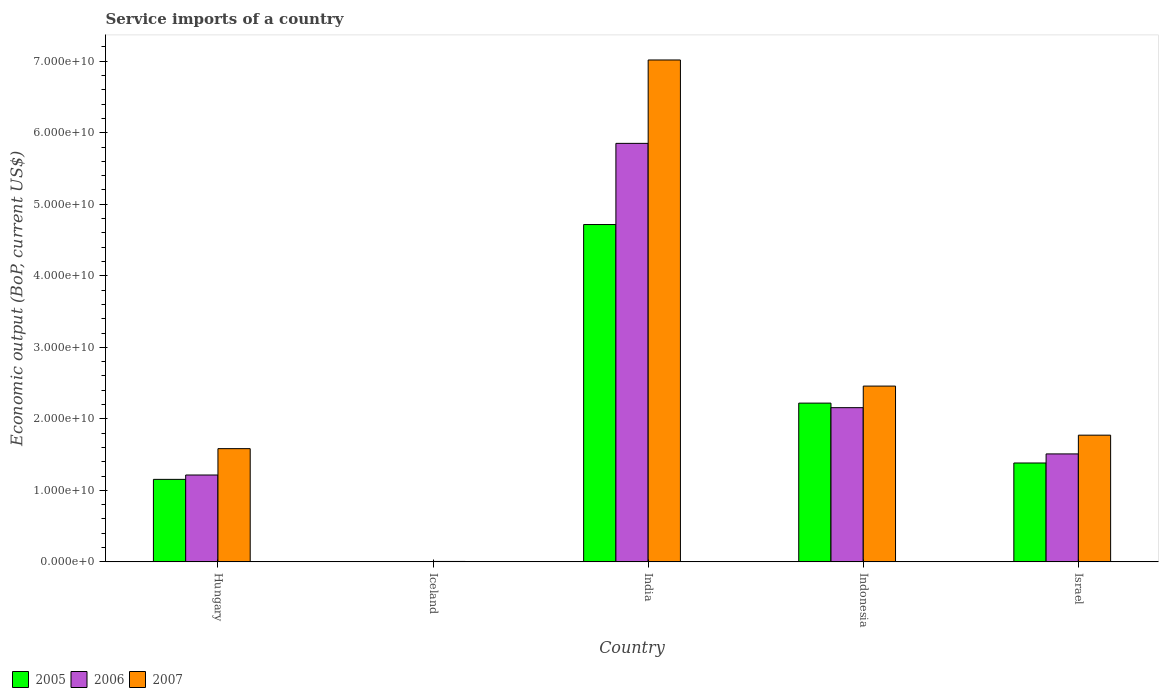How many different coloured bars are there?
Your answer should be very brief. 3. What is the label of the 2nd group of bars from the left?
Keep it short and to the point. Iceland. What is the service imports in 2007 in Israel?
Ensure brevity in your answer.  1.77e+1. Across all countries, what is the maximum service imports in 2007?
Keep it short and to the point. 7.02e+1. Across all countries, what is the minimum service imports in 2006?
Offer a terse response. 2.89e+07. In which country was the service imports in 2007 maximum?
Make the answer very short. India. In which country was the service imports in 2006 minimum?
Provide a succinct answer. Iceland. What is the total service imports in 2007 in the graph?
Provide a short and direct response. 1.28e+11. What is the difference between the service imports in 2007 in India and that in Israel?
Ensure brevity in your answer.  5.25e+1. What is the difference between the service imports in 2006 in Iceland and the service imports in 2007 in India?
Your answer should be very brief. -7.01e+1. What is the average service imports in 2006 per country?
Make the answer very short. 2.15e+1. What is the difference between the service imports of/in 2006 and service imports of/in 2007 in Israel?
Your answer should be very brief. -2.62e+09. In how many countries, is the service imports in 2006 greater than 46000000000 US$?
Give a very brief answer. 1. What is the ratio of the service imports in 2005 in Iceland to that in India?
Provide a short and direct response. 0. Is the service imports in 2007 in Iceland less than that in Indonesia?
Offer a terse response. Yes. What is the difference between the highest and the second highest service imports in 2006?
Make the answer very short. -4.34e+1. What is the difference between the highest and the lowest service imports in 2005?
Offer a terse response. 4.72e+1. Is it the case that in every country, the sum of the service imports in 2006 and service imports in 2005 is greater than the service imports in 2007?
Give a very brief answer. No. Are all the bars in the graph horizontal?
Your answer should be very brief. No. How many countries are there in the graph?
Provide a succinct answer. 5. Does the graph contain any zero values?
Provide a short and direct response. No. Does the graph contain grids?
Ensure brevity in your answer.  No. Where does the legend appear in the graph?
Keep it short and to the point. Bottom left. How are the legend labels stacked?
Your response must be concise. Horizontal. What is the title of the graph?
Keep it short and to the point. Service imports of a country. Does "2008" appear as one of the legend labels in the graph?
Ensure brevity in your answer.  No. What is the label or title of the Y-axis?
Offer a terse response. Economic output (BoP, current US$). What is the Economic output (BoP, current US$) of 2005 in Hungary?
Your response must be concise. 1.15e+1. What is the Economic output (BoP, current US$) of 2006 in Hungary?
Provide a short and direct response. 1.21e+1. What is the Economic output (BoP, current US$) of 2007 in Hungary?
Provide a short and direct response. 1.58e+1. What is the Economic output (BoP, current US$) of 2005 in Iceland?
Keep it short and to the point. 1.32e+07. What is the Economic output (BoP, current US$) in 2006 in Iceland?
Offer a very short reply. 2.89e+07. What is the Economic output (BoP, current US$) in 2007 in Iceland?
Offer a very short reply. 5.90e+07. What is the Economic output (BoP, current US$) in 2005 in India?
Give a very brief answer. 4.72e+1. What is the Economic output (BoP, current US$) in 2006 in India?
Provide a short and direct response. 5.85e+1. What is the Economic output (BoP, current US$) in 2007 in India?
Ensure brevity in your answer.  7.02e+1. What is the Economic output (BoP, current US$) of 2005 in Indonesia?
Provide a short and direct response. 2.22e+1. What is the Economic output (BoP, current US$) of 2006 in Indonesia?
Offer a very short reply. 2.16e+1. What is the Economic output (BoP, current US$) in 2007 in Indonesia?
Make the answer very short. 2.46e+1. What is the Economic output (BoP, current US$) in 2005 in Israel?
Offer a terse response. 1.38e+1. What is the Economic output (BoP, current US$) in 2006 in Israel?
Provide a short and direct response. 1.51e+1. What is the Economic output (BoP, current US$) in 2007 in Israel?
Give a very brief answer. 1.77e+1. Across all countries, what is the maximum Economic output (BoP, current US$) in 2005?
Make the answer very short. 4.72e+1. Across all countries, what is the maximum Economic output (BoP, current US$) of 2006?
Make the answer very short. 5.85e+1. Across all countries, what is the maximum Economic output (BoP, current US$) of 2007?
Give a very brief answer. 7.02e+1. Across all countries, what is the minimum Economic output (BoP, current US$) in 2005?
Offer a terse response. 1.32e+07. Across all countries, what is the minimum Economic output (BoP, current US$) of 2006?
Ensure brevity in your answer.  2.89e+07. Across all countries, what is the minimum Economic output (BoP, current US$) of 2007?
Your answer should be very brief. 5.90e+07. What is the total Economic output (BoP, current US$) of 2005 in the graph?
Offer a very short reply. 9.47e+1. What is the total Economic output (BoP, current US$) in 2006 in the graph?
Ensure brevity in your answer.  1.07e+11. What is the total Economic output (BoP, current US$) in 2007 in the graph?
Offer a terse response. 1.28e+11. What is the difference between the Economic output (BoP, current US$) of 2005 in Hungary and that in Iceland?
Make the answer very short. 1.15e+1. What is the difference between the Economic output (BoP, current US$) of 2006 in Hungary and that in Iceland?
Keep it short and to the point. 1.21e+1. What is the difference between the Economic output (BoP, current US$) of 2007 in Hungary and that in Iceland?
Your answer should be very brief. 1.58e+1. What is the difference between the Economic output (BoP, current US$) in 2005 in Hungary and that in India?
Provide a short and direct response. -3.56e+1. What is the difference between the Economic output (BoP, current US$) of 2006 in Hungary and that in India?
Provide a short and direct response. -4.64e+1. What is the difference between the Economic output (BoP, current US$) in 2007 in Hungary and that in India?
Your response must be concise. -5.43e+1. What is the difference between the Economic output (BoP, current US$) of 2005 in Hungary and that in Indonesia?
Offer a terse response. -1.07e+1. What is the difference between the Economic output (BoP, current US$) in 2006 in Hungary and that in Indonesia?
Offer a terse response. -9.42e+09. What is the difference between the Economic output (BoP, current US$) in 2007 in Hungary and that in Indonesia?
Your response must be concise. -8.75e+09. What is the difference between the Economic output (BoP, current US$) of 2005 in Hungary and that in Israel?
Give a very brief answer. -2.29e+09. What is the difference between the Economic output (BoP, current US$) of 2006 in Hungary and that in Israel?
Offer a very short reply. -2.95e+09. What is the difference between the Economic output (BoP, current US$) in 2007 in Hungary and that in Israel?
Give a very brief answer. -1.89e+09. What is the difference between the Economic output (BoP, current US$) in 2005 in Iceland and that in India?
Keep it short and to the point. -4.72e+1. What is the difference between the Economic output (BoP, current US$) of 2006 in Iceland and that in India?
Make the answer very short. -5.85e+1. What is the difference between the Economic output (BoP, current US$) of 2007 in Iceland and that in India?
Provide a short and direct response. -7.01e+1. What is the difference between the Economic output (BoP, current US$) in 2005 in Iceland and that in Indonesia?
Your answer should be very brief. -2.22e+1. What is the difference between the Economic output (BoP, current US$) of 2006 in Iceland and that in Indonesia?
Make the answer very short. -2.15e+1. What is the difference between the Economic output (BoP, current US$) of 2007 in Iceland and that in Indonesia?
Offer a terse response. -2.45e+1. What is the difference between the Economic output (BoP, current US$) in 2005 in Iceland and that in Israel?
Your answer should be compact. -1.38e+1. What is the difference between the Economic output (BoP, current US$) of 2006 in Iceland and that in Israel?
Provide a short and direct response. -1.51e+1. What is the difference between the Economic output (BoP, current US$) in 2007 in Iceland and that in Israel?
Your answer should be very brief. -1.77e+1. What is the difference between the Economic output (BoP, current US$) of 2005 in India and that in Indonesia?
Your response must be concise. 2.50e+1. What is the difference between the Economic output (BoP, current US$) of 2006 in India and that in Indonesia?
Provide a short and direct response. 3.70e+1. What is the difference between the Economic output (BoP, current US$) of 2007 in India and that in Indonesia?
Give a very brief answer. 4.56e+1. What is the difference between the Economic output (BoP, current US$) in 2005 in India and that in Israel?
Ensure brevity in your answer.  3.33e+1. What is the difference between the Economic output (BoP, current US$) in 2006 in India and that in Israel?
Keep it short and to the point. 4.34e+1. What is the difference between the Economic output (BoP, current US$) in 2007 in India and that in Israel?
Provide a succinct answer. 5.25e+1. What is the difference between the Economic output (BoP, current US$) in 2005 in Indonesia and that in Israel?
Offer a very short reply. 8.37e+09. What is the difference between the Economic output (BoP, current US$) in 2006 in Indonesia and that in Israel?
Give a very brief answer. 6.47e+09. What is the difference between the Economic output (BoP, current US$) of 2007 in Indonesia and that in Israel?
Ensure brevity in your answer.  6.86e+09. What is the difference between the Economic output (BoP, current US$) of 2005 in Hungary and the Economic output (BoP, current US$) of 2006 in Iceland?
Provide a short and direct response. 1.15e+1. What is the difference between the Economic output (BoP, current US$) of 2005 in Hungary and the Economic output (BoP, current US$) of 2007 in Iceland?
Your response must be concise. 1.15e+1. What is the difference between the Economic output (BoP, current US$) of 2006 in Hungary and the Economic output (BoP, current US$) of 2007 in Iceland?
Your answer should be compact. 1.21e+1. What is the difference between the Economic output (BoP, current US$) of 2005 in Hungary and the Economic output (BoP, current US$) of 2006 in India?
Make the answer very short. -4.70e+1. What is the difference between the Economic output (BoP, current US$) in 2005 in Hungary and the Economic output (BoP, current US$) in 2007 in India?
Make the answer very short. -5.86e+1. What is the difference between the Economic output (BoP, current US$) of 2006 in Hungary and the Economic output (BoP, current US$) of 2007 in India?
Your answer should be compact. -5.80e+1. What is the difference between the Economic output (BoP, current US$) of 2005 in Hungary and the Economic output (BoP, current US$) of 2006 in Indonesia?
Offer a terse response. -1.00e+1. What is the difference between the Economic output (BoP, current US$) in 2005 in Hungary and the Economic output (BoP, current US$) in 2007 in Indonesia?
Your answer should be very brief. -1.30e+1. What is the difference between the Economic output (BoP, current US$) in 2006 in Hungary and the Economic output (BoP, current US$) in 2007 in Indonesia?
Your answer should be very brief. -1.24e+1. What is the difference between the Economic output (BoP, current US$) of 2005 in Hungary and the Economic output (BoP, current US$) of 2006 in Israel?
Provide a succinct answer. -3.56e+09. What is the difference between the Economic output (BoP, current US$) of 2005 in Hungary and the Economic output (BoP, current US$) of 2007 in Israel?
Your response must be concise. -6.18e+09. What is the difference between the Economic output (BoP, current US$) of 2006 in Hungary and the Economic output (BoP, current US$) of 2007 in Israel?
Your answer should be compact. -5.57e+09. What is the difference between the Economic output (BoP, current US$) of 2005 in Iceland and the Economic output (BoP, current US$) of 2006 in India?
Your answer should be very brief. -5.85e+1. What is the difference between the Economic output (BoP, current US$) of 2005 in Iceland and the Economic output (BoP, current US$) of 2007 in India?
Offer a very short reply. -7.02e+1. What is the difference between the Economic output (BoP, current US$) in 2006 in Iceland and the Economic output (BoP, current US$) in 2007 in India?
Give a very brief answer. -7.01e+1. What is the difference between the Economic output (BoP, current US$) in 2005 in Iceland and the Economic output (BoP, current US$) in 2006 in Indonesia?
Give a very brief answer. -2.15e+1. What is the difference between the Economic output (BoP, current US$) in 2005 in Iceland and the Economic output (BoP, current US$) in 2007 in Indonesia?
Provide a short and direct response. -2.46e+1. What is the difference between the Economic output (BoP, current US$) in 2006 in Iceland and the Economic output (BoP, current US$) in 2007 in Indonesia?
Ensure brevity in your answer.  -2.45e+1. What is the difference between the Economic output (BoP, current US$) in 2005 in Iceland and the Economic output (BoP, current US$) in 2006 in Israel?
Give a very brief answer. -1.51e+1. What is the difference between the Economic output (BoP, current US$) of 2005 in Iceland and the Economic output (BoP, current US$) of 2007 in Israel?
Give a very brief answer. -1.77e+1. What is the difference between the Economic output (BoP, current US$) in 2006 in Iceland and the Economic output (BoP, current US$) in 2007 in Israel?
Give a very brief answer. -1.77e+1. What is the difference between the Economic output (BoP, current US$) of 2005 in India and the Economic output (BoP, current US$) of 2006 in Indonesia?
Offer a terse response. 2.56e+1. What is the difference between the Economic output (BoP, current US$) of 2005 in India and the Economic output (BoP, current US$) of 2007 in Indonesia?
Ensure brevity in your answer.  2.26e+1. What is the difference between the Economic output (BoP, current US$) of 2006 in India and the Economic output (BoP, current US$) of 2007 in Indonesia?
Keep it short and to the point. 3.39e+1. What is the difference between the Economic output (BoP, current US$) of 2005 in India and the Economic output (BoP, current US$) of 2006 in Israel?
Your answer should be very brief. 3.21e+1. What is the difference between the Economic output (BoP, current US$) in 2005 in India and the Economic output (BoP, current US$) in 2007 in Israel?
Ensure brevity in your answer.  2.94e+1. What is the difference between the Economic output (BoP, current US$) in 2006 in India and the Economic output (BoP, current US$) in 2007 in Israel?
Ensure brevity in your answer.  4.08e+1. What is the difference between the Economic output (BoP, current US$) in 2005 in Indonesia and the Economic output (BoP, current US$) in 2006 in Israel?
Make the answer very short. 7.10e+09. What is the difference between the Economic output (BoP, current US$) in 2005 in Indonesia and the Economic output (BoP, current US$) in 2007 in Israel?
Keep it short and to the point. 4.48e+09. What is the difference between the Economic output (BoP, current US$) of 2006 in Indonesia and the Economic output (BoP, current US$) of 2007 in Israel?
Offer a terse response. 3.84e+09. What is the average Economic output (BoP, current US$) of 2005 per country?
Your answer should be very brief. 1.89e+1. What is the average Economic output (BoP, current US$) of 2006 per country?
Your answer should be very brief. 2.15e+1. What is the average Economic output (BoP, current US$) of 2007 per country?
Offer a terse response. 2.57e+1. What is the difference between the Economic output (BoP, current US$) in 2005 and Economic output (BoP, current US$) in 2006 in Hungary?
Provide a succinct answer. -6.10e+08. What is the difference between the Economic output (BoP, current US$) of 2005 and Economic output (BoP, current US$) of 2007 in Hungary?
Provide a short and direct response. -4.30e+09. What is the difference between the Economic output (BoP, current US$) of 2006 and Economic output (BoP, current US$) of 2007 in Hungary?
Your answer should be compact. -3.69e+09. What is the difference between the Economic output (BoP, current US$) in 2005 and Economic output (BoP, current US$) in 2006 in Iceland?
Ensure brevity in your answer.  -1.57e+07. What is the difference between the Economic output (BoP, current US$) of 2005 and Economic output (BoP, current US$) of 2007 in Iceland?
Offer a very short reply. -4.58e+07. What is the difference between the Economic output (BoP, current US$) in 2006 and Economic output (BoP, current US$) in 2007 in Iceland?
Give a very brief answer. -3.01e+07. What is the difference between the Economic output (BoP, current US$) in 2005 and Economic output (BoP, current US$) in 2006 in India?
Your answer should be very brief. -1.13e+1. What is the difference between the Economic output (BoP, current US$) in 2005 and Economic output (BoP, current US$) in 2007 in India?
Give a very brief answer. -2.30e+1. What is the difference between the Economic output (BoP, current US$) of 2006 and Economic output (BoP, current US$) of 2007 in India?
Provide a short and direct response. -1.17e+1. What is the difference between the Economic output (BoP, current US$) of 2005 and Economic output (BoP, current US$) of 2006 in Indonesia?
Make the answer very short. 6.36e+08. What is the difference between the Economic output (BoP, current US$) of 2005 and Economic output (BoP, current US$) of 2007 in Indonesia?
Make the answer very short. -2.38e+09. What is the difference between the Economic output (BoP, current US$) of 2006 and Economic output (BoP, current US$) of 2007 in Indonesia?
Your answer should be compact. -3.02e+09. What is the difference between the Economic output (BoP, current US$) in 2005 and Economic output (BoP, current US$) in 2006 in Israel?
Offer a very short reply. -1.27e+09. What is the difference between the Economic output (BoP, current US$) in 2005 and Economic output (BoP, current US$) in 2007 in Israel?
Your answer should be very brief. -3.89e+09. What is the difference between the Economic output (BoP, current US$) in 2006 and Economic output (BoP, current US$) in 2007 in Israel?
Offer a terse response. -2.62e+09. What is the ratio of the Economic output (BoP, current US$) in 2005 in Hungary to that in Iceland?
Make the answer very short. 871.84. What is the ratio of the Economic output (BoP, current US$) of 2006 in Hungary to that in Iceland?
Make the answer very short. 419.96. What is the ratio of the Economic output (BoP, current US$) of 2007 in Hungary to that in Iceland?
Make the answer very short. 268.36. What is the ratio of the Economic output (BoP, current US$) in 2005 in Hungary to that in India?
Provide a succinct answer. 0.24. What is the ratio of the Economic output (BoP, current US$) in 2006 in Hungary to that in India?
Provide a short and direct response. 0.21. What is the ratio of the Economic output (BoP, current US$) in 2007 in Hungary to that in India?
Your answer should be very brief. 0.23. What is the ratio of the Economic output (BoP, current US$) of 2005 in Hungary to that in Indonesia?
Make the answer very short. 0.52. What is the ratio of the Economic output (BoP, current US$) in 2006 in Hungary to that in Indonesia?
Your response must be concise. 0.56. What is the ratio of the Economic output (BoP, current US$) in 2007 in Hungary to that in Indonesia?
Give a very brief answer. 0.64. What is the ratio of the Economic output (BoP, current US$) in 2005 in Hungary to that in Israel?
Provide a succinct answer. 0.83. What is the ratio of the Economic output (BoP, current US$) in 2006 in Hungary to that in Israel?
Your response must be concise. 0.8. What is the ratio of the Economic output (BoP, current US$) in 2007 in Hungary to that in Israel?
Provide a succinct answer. 0.89. What is the ratio of the Economic output (BoP, current US$) in 2006 in Iceland to that in India?
Your answer should be very brief. 0. What is the ratio of the Economic output (BoP, current US$) of 2007 in Iceland to that in India?
Keep it short and to the point. 0. What is the ratio of the Economic output (BoP, current US$) of 2005 in Iceland to that in Indonesia?
Provide a succinct answer. 0. What is the ratio of the Economic output (BoP, current US$) of 2006 in Iceland to that in Indonesia?
Offer a terse response. 0. What is the ratio of the Economic output (BoP, current US$) in 2007 in Iceland to that in Indonesia?
Make the answer very short. 0. What is the ratio of the Economic output (BoP, current US$) of 2006 in Iceland to that in Israel?
Keep it short and to the point. 0. What is the ratio of the Economic output (BoP, current US$) of 2007 in Iceland to that in Israel?
Offer a terse response. 0. What is the ratio of the Economic output (BoP, current US$) of 2005 in India to that in Indonesia?
Offer a terse response. 2.12. What is the ratio of the Economic output (BoP, current US$) in 2006 in India to that in Indonesia?
Keep it short and to the point. 2.71. What is the ratio of the Economic output (BoP, current US$) of 2007 in India to that in Indonesia?
Offer a very short reply. 2.86. What is the ratio of the Economic output (BoP, current US$) of 2005 in India to that in Israel?
Ensure brevity in your answer.  3.41. What is the ratio of the Economic output (BoP, current US$) in 2006 in India to that in Israel?
Provide a succinct answer. 3.88. What is the ratio of the Economic output (BoP, current US$) of 2007 in India to that in Israel?
Your answer should be compact. 3.96. What is the ratio of the Economic output (BoP, current US$) of 2005 in Indonesia to that in Israel?
Provide a short and direct response. 1.61. What is the ratio of the Economic output (BoP, current US$) of 2006 in Indonesia to that in Israel?
Make the answer very short. 1.43. What is the ratio of the Economic output (BoP, current US$) of 2007 in Indonesia to that in Israel?
Give a very brief answer. 1.39. What is the difference between the highest and the second highest Economic output (BoP, current US$) in 2005?
Your answer should be very brief. 2.50e+1. What is the difference between the highest and the second highest Economic output (BoP, current US$) of 2006?
Offer a terse response. 3.70e+1. What is the difference between the highest and the second highest Economic output (BoP, current US$) of 2007?
Provide a short and direct response. 4.56e+1. What is the difference between the highest and the lowest Economic output (BoP, current US$) in 2005?
Offer a very short reply. 4.72e+1. What is the difference between the highest and the lowest Economic output (BoP, current US$) of 2006?
Your answer should be very brief. 5.85e+1. What is the difference between the highest and the lowest Economic output (BoP, current US$) in 2007?
Provide a succinct answer. 7.01e+1. 